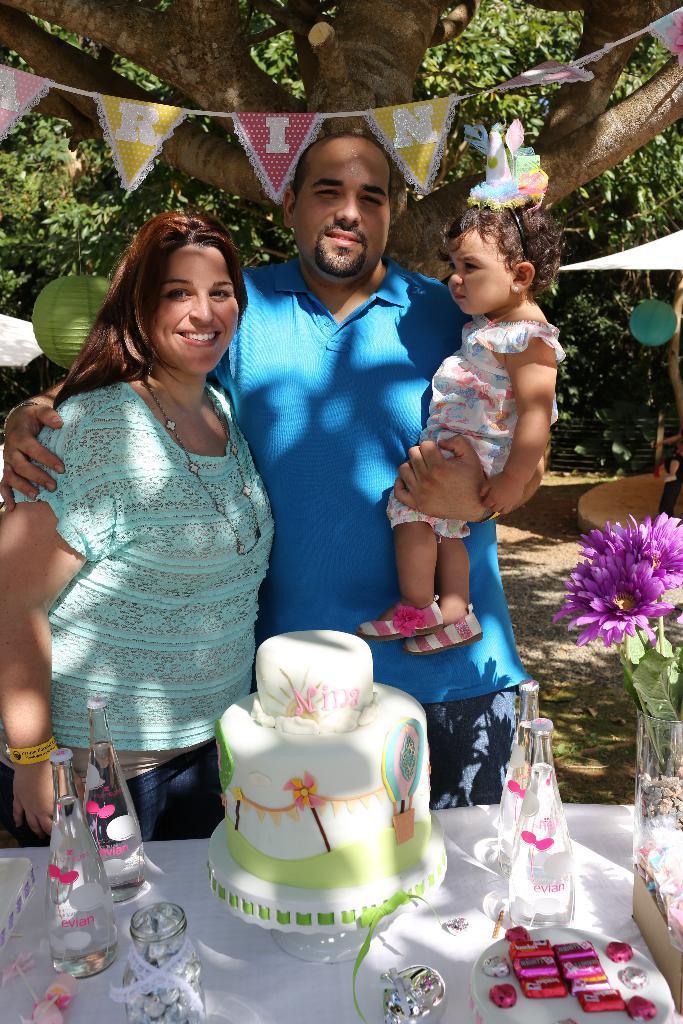Describe this image in one or two sentences. In this picture I can see a man and a woman, the man is carrying a kid, there are bottles, cake, chocolates and some other items on the table, there are decorative flags, paper lanterns, and in the background there are trees. 